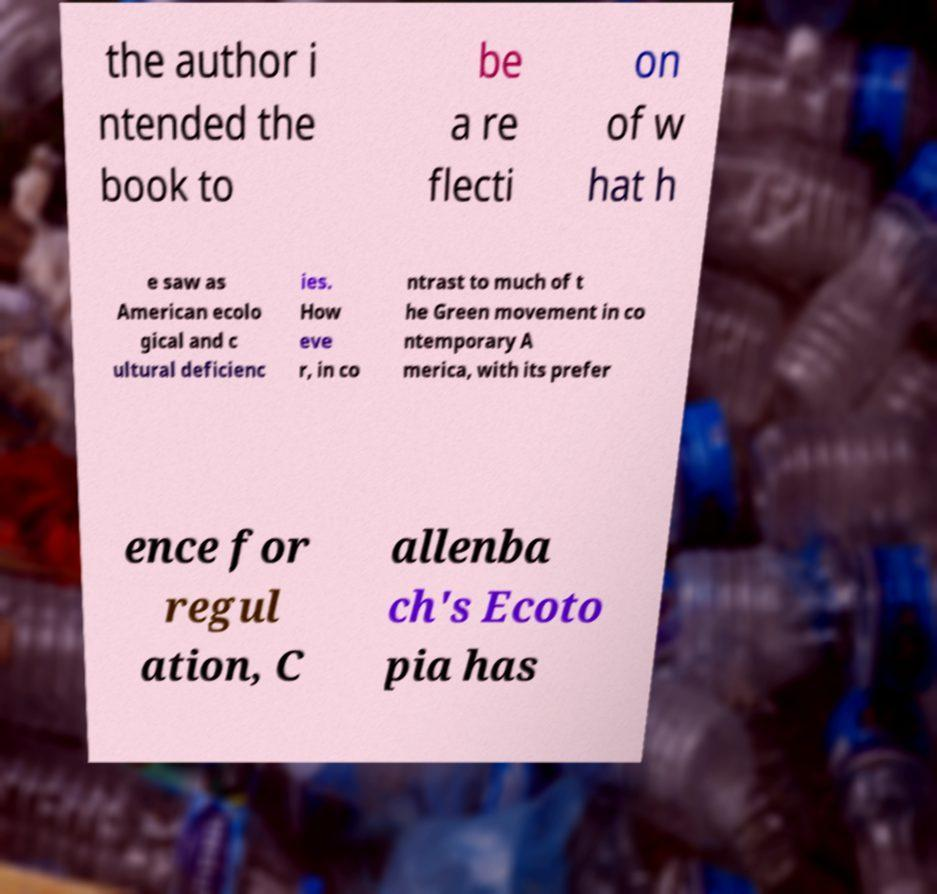I need the written content from this picture converted into text. Can you do that? the author i ntended the book to be a re flecti on of w hat h e saw as American ecolo gical and c ultural deficienc ies. How eve r, in co ntrast to much of t he Green movement in co ntemporary A merica, with its prefer ence for regul ation, C allenba ch's Ecoto pia has 